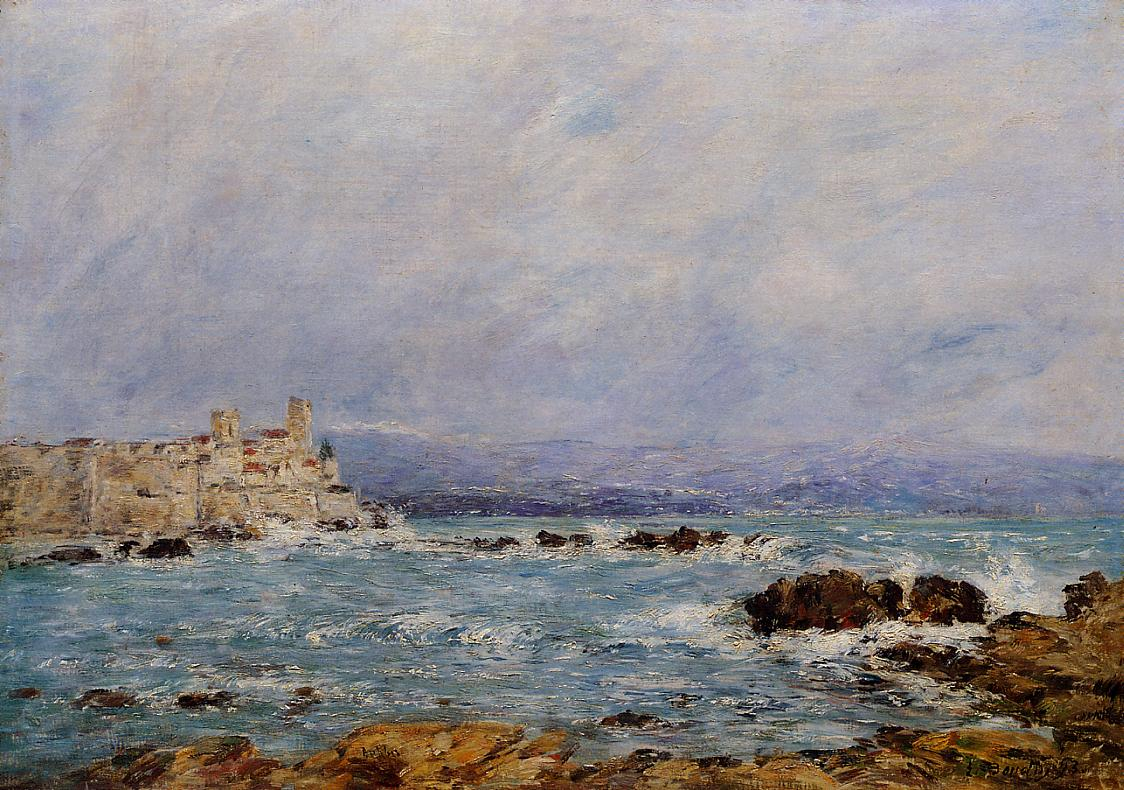Imagine you are standing in this scene. Describe the sensory experiences you might have. Standing on the mossy rocks, you'd feel the cool, moist texture underfoot and the salty breeze rustling through your hair. The rhythmic sound of waves crashing and retreating would be calming, occasionally punctuated by the distant call of seabirds. The scent of the sea, a mix of saltwater and fresh marine life, would fill your lungs. The sight of the sun reflecting off the castle's sandy facade and the glistening ocean would be striking, blending earthy tones with the vibrant blues of the water and sky. 